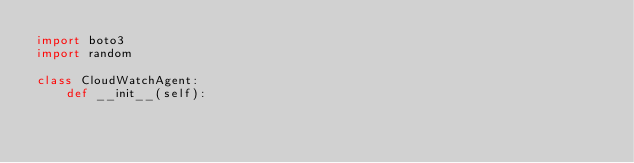<code> <loc_0><loc_0><loc_500><loc_500><_Python_>import boto3
import random

class CloudWatchAgent:
    def __init__(self):</code> 